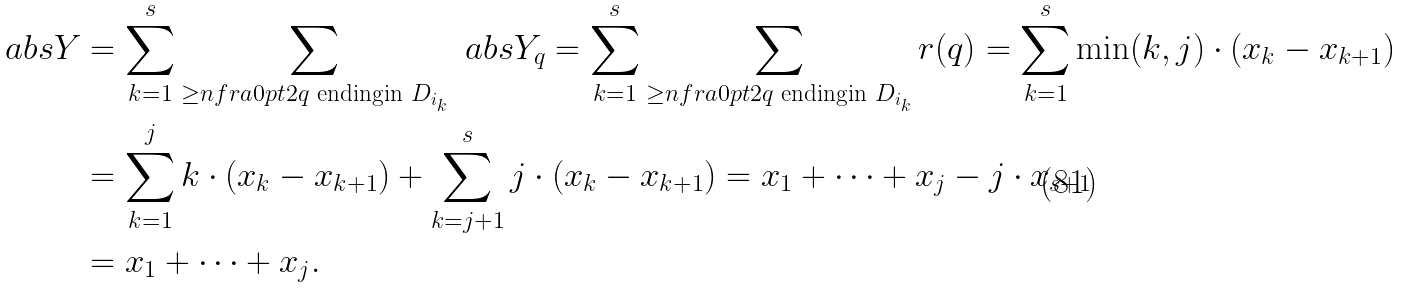<formula> <loc_0><loc_0><loc_500><loc_500>\ a b s { Y } & = \sum _ { k = 1 } ^ { s } \sum _ { \geq n f r a { } { 0 p t } { 2 } { q \text { ending} } { \text {in } D _ { i _ { k } } } } \ a b s { Y _ { q } } = \sum _ { k = 1 } ^ { s } \sum _ { \geq n f r a { } { 0 p t } { 2 } { q \text { ending} } { \text {in } D _ { i _ { k } } } } r ( q ) = \sum _ { k = 1 } ^ { s } \min ( k , j ) \cdot ( x _ { k } - x _ { k + 1 } ) \\ & = \sum _ { k = 1 } ^ { j } k \cdot ( x _ { k } - x _ { k + 1 } ) + \sum _ { k = j + 1 } ^ { s } j \cdot ( x _ { k } - x _ { k + 1 } ) = x _ { 1 } + \dots + x _ { j } - j \cdot x _ { s + 1 } \\ & = x _ { 1 } + \dots + x _ { j } .</formula> 